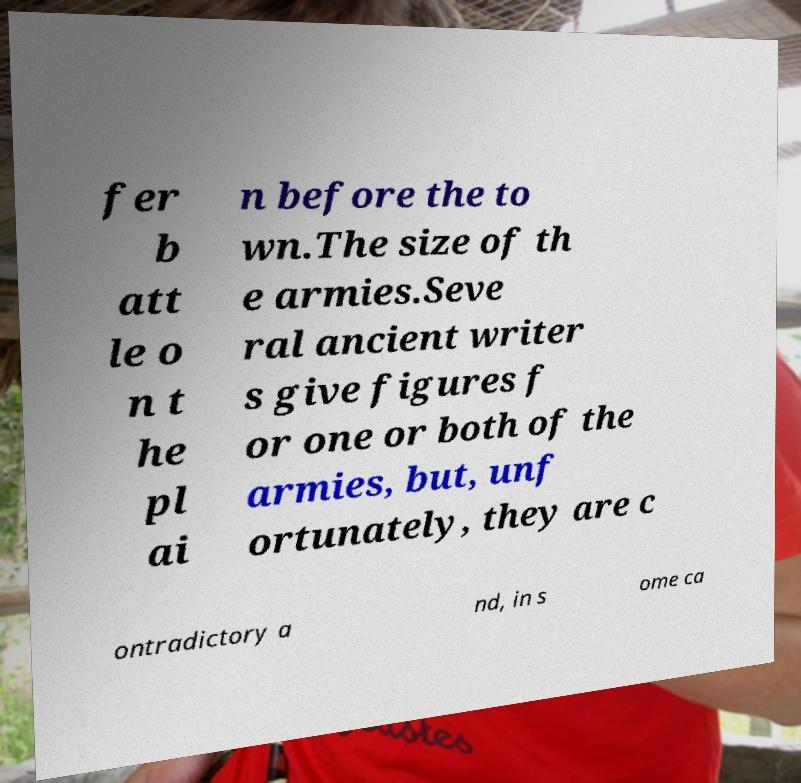What messages or text are displayed in this image? I need them in a readable, typed format. fer b att le o n t he pl ai n before the to wn.The size of th e armies.Seve ral ancient writer s give figures f or one or both of the armies, but, unf ortunately, they are c ontradictory a nd, in s ome ca 